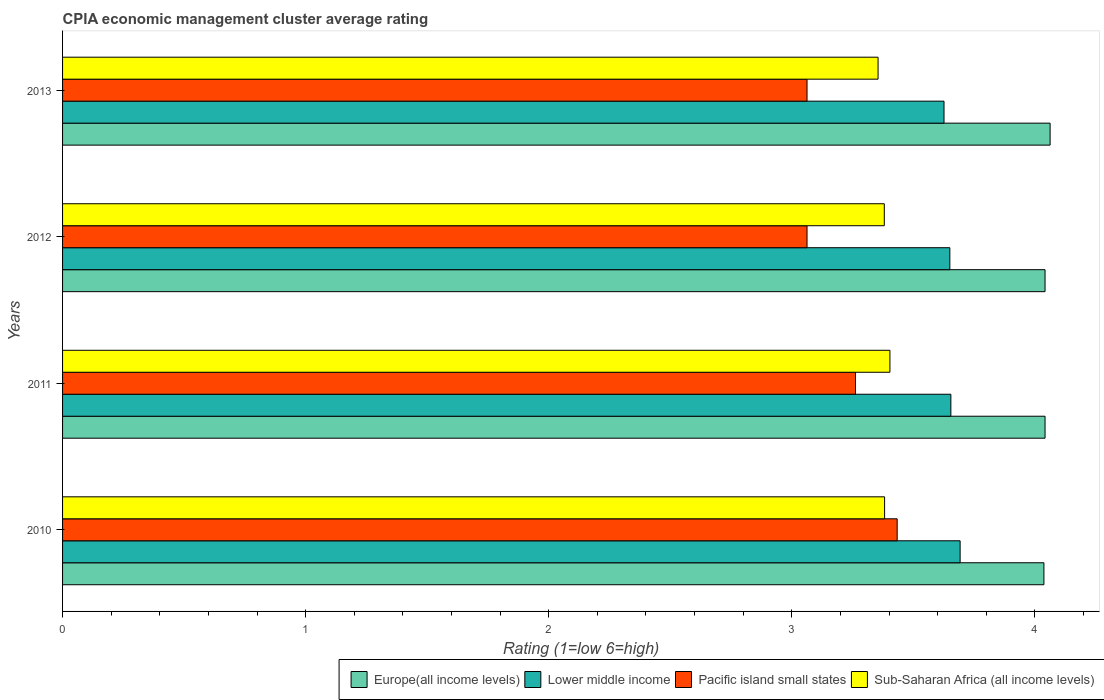How many bars are there on the 3rd tick from the bottom?
Make the answer very short. 4. What is the label of the 1st group of bars from the top?
Give a very brief answer. 2013. What is the CPIA rating in Pacific island small states in 2013?
Your response must be concise. 3.06. Across all years, what is the maximum CPIA rating in Europe(all income levels)?
Provide a succinct answer. 4.06. Across all years, what is the minimum CPIA rating in Pacific island small states?
Make the answer very short. 3.06. In which year was the CPIA rating in Pacific island small states maximum?
Offer a very short reply. 2010. What is the total CPIA rating in Lower middle income in the graph?
Offer a terse response. 14.62. What is the difference between the CPIA rating in Europe(all income levels) in 2010 and that in 2012?
Ensure brevity in your answer.  -0. What is the difference between the CPIA rating in Lower middle income in 2010 and the CPIA rating in Pacific island small states in 2012?
Your answer should be compact. 0.63. What is the average CPIA rating in Lower middle income per year?
Make the answer very short. 3.66. In the year 2011, what is the difference between the CPIA rating in Sub-Saharan Africa (all income levels) and CPIA rating in Europe(all income levels)?
Give a very brief answer. -0.64. In how many years, is the CPIA rating in Sub-Saharan Africa (all income levels) greater than 2.6 ?
Offer a terse response. 4. What is the ratio of the CPIA rating in Lower middle income in 2010 to that in 2013?
Make the answer very short. 1.02. What is the difference between the highest and the second highest CPIA rating in Pacific island small states?
Your answer should be very brief. 0.17. What is the difference between the highest and the lowest CPIA rating in Europe(all income levels)?
Give a very brief answer. 0.03. What does the 1st bar from the top in 2010 represents?
Make the answer very short. Sub-Saharan Africa (all income levels). What does the 1st bar from the bottom in 2012 represents?
Keep it short and to the point. Europe(all income levels). Is it the case that in every year, the sum of the CPIA rating in Pacific island small states and CPIA rating in Sub-Saharan Africa (all income levels) is greater than the CPIA rating in Europe(all income levels)?
Provide a succinct answer. Yes. How many bars are there?
Offer a very short reply. 16. How many years are there in the graph?
Your answer should be very brief. 4. What is the difference between two consecutive major ticks on the X-axis?
Give a very brief answer. 1. Does the graph contain any zero values?
Keep it short and to the point. No. Does the graph contain grids?
Provide a short and direct response. No. How are the legend labels stacked?
Provide a succinct answer. Horizontal. What is the title of the graph?
Keep it short and to the point. CPIA economic management cluster average rating. Does "High income" appear as one of the legend labels in the graph?
Provide a short and direct response. No. What is the label or title of the X-axis?
Offer a very short reply. Rating (1=low 6=high). What is the label or title of the Y-axis?
Provide a short and direct response. Years. What is the Rating (1=low 6=high) of Europe(all income levels) in 2010?
Ensure brevity in your answer.  4.04. What is the Rating (1=low 6=high) in Lower middle income in 2010?
Your answer should be very brief. 3.69. What is the Rating (1=low 6=high) in Pacific island small states in 2010?
Your response must be concise. 3.43. What is the Rating (1=low 6=high) in Sub-Saharan Africa (all income levels) in 2010?
Give a very brief answer. 3.38. What is the Rating (1=low 6=high) in Europe(all income levels) in 2011?
Provide a succinct answer. 4.04. What is the Rating (1=low 6=high) of Lower middle income in 2011?
Provide a succinct answer. 3.65. What is the Rating (1=low 6=high) of Pacific island small states in 2011?
Offer a very short reply. 3.26. What is the Rating (1=low 6=high) of Sub-Saharan Africa (all income levels) in 2011?
Keep it short and to the point. 3.4. What is the Rating (1=low 6=high) of Europe(all income levels) in 2012?
Offer a terse response. 4.04. What is the Rating (1=low 6=high) of Lower middle income in 2012?
Ensure brevity in your answer.  3.65. What is the Rating (1=low 6=high) of Pacific island small states in 2012?
Ensure brevity in your answer.  3.06. What is the Rating (1=low 6=high) of Sub-Saharan Africa (all income levels) in 2012?
Ensure brevity in your answer.  3.38. What is the Rating (1=low 6=high) of Europe(all income levels) in 2013?
Keep it short and to the point. 4.06. What is the Rating (1=low 6=high) of Lower middle income in 2013?
Your answer should be compact. 3.63. What is the Rating (1=low 6=high) in Pacific island small states in 2013?
Offer a very short reply. 3.06. What is the Rating (1=low 6=high) of Sub-Saharan Africa (all income levels) in 2013?
Your response must be concise. 3.35. Across all years, what is the maximum Rating (1=low 6=high) in Europe(all income levels)?
Your response must be concise. 4.06. Across all years, what is the maximum Rating (1=low 6=high) of Lower middle income?
Ensure brevity in your answer.  3.69. Across all years, what is the maximum Rating (1=low 6=high) in Pacific island small states?
Keep it short and to the point. 3.43. Across all years, what is the maximum Rating (1=low 6=high) of Sub-Saharan Africa (all income levels)?
Provide a short and direct response. 3.4. Across all years, what is the minimum Rating (1=low 6=high) in Europe(all income levels)?
Ensure brevity in your answer.  4.04. Across all years, what is the minimum Rating (1=low 6=high) of Lower middle income?
Keep it short and to the point. 3.63. Across all years, what is the minimum Rating (1=low 6=high) in Pacific island small states?
Keep it short and to the point. 3.06. Across all years, what is the minimum Rating (1=low 6=high) in Sub-Saharan Africa (all income levels)?
Keep it short and to the point. 3.35. What is the total Rating (1=low 6=high) in Europe(all income levels) in the graph?
Give a very brief answer. 16.18. What is the total Rating (1=low 6=high) in Lower middle income in the graph?
Keep it short and to the point. 14.62. What is the total Rating (1=low 6=high) in Pacific island small states in the graph?
Ensure brevity in your answer.  12.82. What is the total Rating (1=low 6=high) in Sub-Saharan Africa (all income levels) in the graph?
Your answer should be very brief. 13.52. What is the difference between the Rating (1=low 6=high) in Europe(all income levels) in 2010 and that in 2011?
Offer a very short reply. -0. What is the difference between the Rating (1=low 6=high) of Lower middle income in 2010 and that in 2011?
Your answer should be compact. 0.04. What is the difference between the Rating (1=low 6=high) of Pacific island small states in 2010 and that in 2011?
Make the answer very short. 0.17. What is the difference between the Rating (1=low 6=high) of Sub-Saharan Africa (all income levels) in 2010 and that in 2011?
Give a very brief answer. -0.02. What is the difference between the Rating (1=low 6=high) in Europe(all income levels) in 2010 and that in 2012?
Your answer should be very brief. -0. What is the difference between the Rating (1=low 6=high) of Lower middle income in 2010 and that in 2012?
Give a very brief answer. 0.04. What is the difference between the Rating (1=low 6=high) in Pacific island small states in 2010 and that in 2012?
Your response must be concise. 0.37. What is the difference between the Rating (1=low 6=high) in Sub-Saharan Africa (all income levels) in 2010 and that in 2012?
Offer a very short reply. 0. What is the difference between the Rating (1=low 6=high) in Europe(all income levels) in 2010 and that in 2013?
Ensure brevity in your answer.  -0.03. What is the difference between the Rating (1=low 6=high) in Lower middle income in 2010 and that in 2013?
Your answer should be very brief. 0.07. What is the difference between the Rating (1=low 6=high) of Pacific island small states in 2010 and that in 2013?
Your answer should be very brief. 0.37. What is the difference between the Rating (1=low 6=high) of Sub-Saharan Africa (all income levels) in 2010 and that in 2013?
Provide a succinct answer. 0.03. What is the difference between the Rating (1=low 6=high) in Europe(all income levels) in 2011 and that in 2012?
Give a very brief answer. 0. What is the difference between the Rating (1=low 6=high) of Lower middle income in 2011 and that in 2012?
Provide a short and direct response. 0. What is the difference between the Rating (1=low 6=high) in Pacific island small states in 2011 and that in 2012?
Provide a succinct answer. 0.2. What is the difference between the Rating (1=low 6=high) of Sub-Saharan Africa (all income levels) in 2011 and that in 2012?
Offer a very short reply. 0.02. What is the difference between the Rating (1=low 6=high) of Europe(all income levels) in 2011 and that in 2013?
Provide a succinct answer. -0.02. What is the difference between the Rating (1=low 6=high) in Lower middle income in 2011 and that in 2013?
Make the answer very short. 0.03. What is the difference between the Rating (1=low 6=high) of Pacific island small states in 2011 and that in 2013?
Give a very brief answer. 0.2. What is the difference between the Rating (1=low 6=high) of Sub-Saharan Africa (all income levels) in 2011 and that in 2013?
Ensure brevity in your answer.  0.05. What is the difference between the Rating (1=low 6=high) in Europe(all income levels) in 2012 and that in 2013?
Offer a very short reply. -0.02. What is the difference between the Rating (1=low 6=high) of Lower middle income in 2012 and that in 2013?
Your response must be concise. 0.02. What is the difference between the Rating (1=low 6=high) in Pacific island small states in 2012 and that in 2013?
Your response must be concise. 0. What is the difference between the Rating (1=low 6=high) in Sub-Saharan Africa (all income levels) in 2012 and that in 2013?
Give a very brief answer. 0.03. What is the difference between the Rating (1=low 6=high) in Europe(all income levels) in 2010 and the Rating (1=low 6=high) in Lower middle income in 2011?
Provide a short and direct response. 0.38. What is the difference between the Rating (1=low 6=high) of Europe(all income levels) in 2010 and the Rating (1=low 6=high) of Pacific island small states in 2011?
Provide a short and direct response. 0.78. What is the difference between the Rating (1=low 6=high) in Europe(all income levels) in 2010 and the Rating (1=low 6=high) in Sub-Saharan Africa (all income levels) in 2011?
Offer a very short reply. 0.63. What is the difference between the Rating (1=low 6=high) in Lower middle income in 2010 and the Rating (1=low 6=high) in Pacific island small states in 2011?
Offer a terse response. 0.43. What is the difference between the Rating (1=low 6=high) in Lower middle income in 2010 and the Rating (1=low 6=high) in Sub-Saharan Africa (all income levels) in 2011?
Ensure brevity in your answer.  0.29. What is the difference between the Rating (1=low 6=high) in Pacific island small states in 2010 and the Rating (1=low 6=high) in Sub-Saharan Africa (all income levels) in 2011?
Your answer should be very brief. 0.03. What is the difference between the Rating (1=low 6=high) in Europe(all income levels) in 2010 and the Rating (1=low 6=high) in Lower middle income in 2012?
Provide a short and direct response. 0.39. What is the difference between the Rating (1=low 6=high) of Europe(all income levels) in 2010 and the Rating (1=low 6=high) of Pacific island small states in 2012?
Make the answer very short. 0.97. What is the difference between the Rating (1=low 6=high) in Europe(all income levels) in 2010 and the Rating (1=low 6=high) in Sub-Saharan Africa (all income levels) in 2012?
Make the answer very short. 0.66. What is the difference between the Rating (1=low 6=high) of Lower middle income in 2010 and the Rating (1=low 6=high) of Pacific island small states in 2012?
Offer a terse response. 0.63. What is the difference between the Rating (1=low 6=high) of Lower middle income in 2010 and the Rating (1=low 6=high) of Sub-Saharan Africa (all income levels) in 2012?
Offer a terse response. 0.31. What is the difference between the Rating (1=low 6=high) of Pacific island small states in 2010 and the Rating (1=low 6=high) of Sub-Saharan Africa (all income levels) in 2012?
Provide a short and direct response. 0.05. What is the difference between the Rating (1=low 6=high) in Europe(all income levels) in 2010 and the Rating (1=low 6=high) in Lower middle income in 2013?
Provide a short and direct response. 0.41. What is the difference between the Rating (1=low 6=high) in Europe(all income levels) in 2010 and the Rating (1=low 6=high) in Pacific island small states in 2013?
Your answer should be compact. 0.97. What is the difference between the Rating (1=low 6=high) in Europe(all income levels) in 2010 and the Rating (1=low 6=high) in Sub-Saharan Africa (all income levels) in 2013?
Your answer should be very brief. 0.68. What is the difference between the Rating (1=low 6=high) in Lower middle income in 2010 and the Rating (1=low 6=high) in Pacific island small states in 2013?
Your answer should be compact. 0.63. What is the difference between the Rating (1=low 6=high) of Lower middle income in 2010 and the Rating (1=low 6=high) of Sub-Saharan Africa (all income levels) in 2013?
Your answer should be very brief. 0.34. What is the difference between the Rating (1=low 6=high) of Pacific island small states in 2010 and the Rating (1=low 6=high) of Sub-Saharan Africa (all income levels) in 2013?
Your answer should be compact. 0.08. What is the difference between the Rating (1=low 6=high) of Europe(all income levels) in 2011 and the Rating (1=low 6=high) of Lower middle income in 2012?
Provide a short and direct response. 0.39. What is the difference between the Rating (1=low 6=high) in Europe(all income levels) in 2011 and the Rating (1=low 6=high) in Pacific island small states in 2012?
Your response must be concise. 0.98. What is the difference between the Rating (1=low 6=high) of Europe(all income levels) in 2011 and the Rating (1=low 6=high) of Sub-Saharan Africa (all income levels) in 2012?
Your answer should be very brief. 0.66. What is the difference between the Rating (1=low 6=high) in Lower middle income in 2011 and the Rating (1=low 6=high) in Pacific island small states in 2012?
Ensure brevity in your answer.  0.59. What is the difference between the Rating (1=low 6=high) in Lower middle income in 2011 and the Rating (1=low 6=high) in Sub-Saharan Africa (all income levels) in 2012?
Offer a very short reply. 0.27. What is the difference between the Rating (1=low 6=high) in Pacific island small states in 2011 and the Rating (1=low 6=high) in Sub-Saharan Africa (all income levels) in 2012?
Give a very brief answer. -0.12. What is the difference between the Rating (1=low 6=high) of Europe(all income levels) in 2011 and the Rating (1=low 6=high) of Lower middle income in 2013?
Keep it short and to the point. 0.42. What is the difference between the Rating (1=low 6=high) of Europe(all income levels) in 2011 and the Rating (1=low 6=high) of Pacific island small states in 2013?
Ensure brevity in your answer.  0.98. What is the difference between the Rating (1=low 6=high) of Europe(all income levels) in 2011 and the Rating (1=low 6=high) of Sub-Saharan Africa (all income levels) in 2013?
Make the answer very short. 0.69. What is the difference between the Rating (1=low 6=high) of Lower middle income in 2011 and the Rating (1=low 6=high) of Pacific island small states in 2013?
Offer a very short reply. 0.59. What is the difference between the Rating (1=low 6=high) of Lower middle income in 2011 and the Rating (1=low 6=high) of Sub-Saharan Africa (all income levels) in 2013?
Offer a terse response. 0.3. What is the difference between the Rating (1=low 6=high) in Pacific island small states in 2011 and the Rating (1=low 6=high) in Sub-Saharan Africa (all income levels) in 2013?
Your response must be concise. -0.09. What is the difference between the Rating (1=low 6=high) of Europe(all income levels) in 2012 and the Rating (1=low 6=high) of Lower middle income in 2013?
Provide a succinct answer. 0.42. What is the difference between the Rating (1=low 6=high) of Europe(all income levels) in 2012 and the Rating (1=low 6=high) of Pacific island small states in 2013?
Your answer should be compact. 0.98. What is the difference between the Rating (1=low 6=high) of Europe(all income levels) in 2012 and the Rating (1=low 6=high) of Sub-Saharan Africa (all income levels) in 2013?
Keep it short and to the point. 0.69. What is the difference between the Rating (1=low 6=high) of Lower middle income in 2012 and the Rating (1=low 6=high) of Pacific island small states in 2013?
Make the answer very short. 0.59. What is the difference between the Rating (1=low 6=high) in Lower middle income in 2012 and the Rating (1=low 6=high) in Sub-Saharan Africa (all income levels) in 2013?
Ensure brevity in your answer.  0.3. What is the difference between the Rating (1=low 6=high) of Pacific island small states in 2012 and the Rating (1=low 6=high) of Sub-Saharan Africa (all income levels) in 2013?
Keep it short and to the point. -0.29. What is the average Rating (1=low 6=high) of Europe(all income levels) per year?
Make the answer very short. 4.05. What is the average Rating (1=low 6=high) in Lower middle income per year?
Ensure brevity in your answer.  3.66. What is the average Rating (1=low 6=high) of Pacific island small states per year?
Offer a terse response. 3.21. What is the average Rating (1=low 6=high) of Sub-Saharan Africa (all income levels) per year?
Provide a short and direct response. 3.38. In the year 2010, what is the difference between the Rating (1=low 6=high) in Europe(all income levels) and Rating (1=low 6=high) in Lower middle income?
Ensure brevity in your answer.  0.34. In the year 2010, what is the difference between the Rating (1=low 6=high) of Europe(all income levels) and Rating (1=low 6=high) of Pacific island small states?
Your response must be concise. 0.6. In the year 2010, what is the difference between the Rating (1=low 6=high) of Europe(all income levels) and Rating (1=low 6=high) of Sub-Saharan Africa (all income levels)?
Offer a very short reply. 0.66. In the year 2010, what is the difference between the Rating (1=low 6=high) in Lower middle income and Rating (1=low 6=high) in Pacific island small states?
Offer a very short reply. 0.26. In the year 2010, what is the difference between the Rating (1=low 6=high) of Lower middle income and Rating (1=low 6=high) of Sub-Saharan Africa (all income levels)?
Your answer should be compact. 0.31. In the year 2010, what is the difference between the Rating (1=low 6=high) in Pacific island small states and Rating (1=low 6=high) in Sub-Saharan Africa (all income levels)?
Provide a short and direct response. 0.05. In the year 2011, what is the difference between the Rating (1=low 6=high) of Europe(all income levels) and Rating (1=low 6=high) of Lower middle income?
Make the answer very short. 0.39. In the year 2011, what is the difference between the Rating (1=low 6=high) in Europe(all income levels) and Rating (1=low 6=high) in Pacific island small states?
Offer a very short reply. 0.78. In the year 2011, what is the difference between the Rating (1=low 6=high) in Europe(all income levels) and Rating (1=low 6=high) in Sub-Saharan Africa (all income levels)?
Provide a succinct answer. 0.64. In the year 2011, what is the difference between the Rating (1=low 6=high) of Lower middle income and Rating (1=low 6=high) of Pacific island small states?
Make the answer very short. 0.39. In the year 2011, what is the difference between the Rating (1=low 6=high) of Lower middle income and Rating (1=low 6=high) of Sub-Saharan Africa (all income levels)?
Ensure brevity in your answer.  0.25. In the year 2011, what is the difference between the Rating (1=low 6=high) in Pacific island small states and Rating (1=low 6=high) in Sub-Saharan Africa (all income levels)?
Provide a succinct answer. -0.14. In the year 2012, what is the difference between the Rating (1=low 6=high) in Europe(all income levels) and Rating (1=low 6=high) in Lower middle income?
Give a very brief answer. 0.39. In the year 2012, what is the difference between the Rating (1=low 6=high) in Europe(all income levels) and Rating (1=low 6=high) in Pacific island small states?
Ensure brevity in your answer.  0.98. In the year 2012, what is the difference between the Rating (1=low 6=high) of Europe(all income levels) and Rating (1=low 6=high) of Sub-Saharan Africa (all income levels)?
Offer a terse response. 0.66. In the year 2012, what is the difference between the Rating (1=low 6=high) in Lower middle income and Rating (1=low 6=high) in Pacific island small states?
Ensure brevity in your answer.  0.59. In the year 2012, what is the difference between the Rating (1=low 6=high) in Lower middle income and Rating (1=low 6=high) in Sub-Saharan Africa (all income levels)?
Your answer should be compact. 0.27. In the year 2012, what is the difference between the Rating (1=low 6=high) of Pacific island small states and Rating (1=low 6=high) of Sub-Saharan Africa (all income levels)?
Provide a succinct answer. -0.32. In the year 2013, what is the difference between the Rating (1=low 6=high) of Europe(all income levels) and Rating (1=low 6=high) of Lower middle income?
Provide a short and direct response. 0.44. In the year 2013, what is the difference between the Rating (1=low 6=high) of Europe(all income levels) and Rating (1=low 6=high) of Pacific island small states?
Make the answer very short. 1. In the year 2013, what is the difference between the Rating (1=low 6=high) of Europe(all income levels) and Rating (1=low 6=high) of Sub-Saharan Africa (all income levels)?
Make the answer very short. 0.71. In the year 2013, what is the difference between the Rating (1=low 6=high) in Lower middle income and Rating (1=low 6=high) in Pacific island small states?
Provide a short and direct response. 0.56. In the year 2013, what is the difference between the Rating (1=low 6=high) of Lower middle income and Rating (1=low 6=high) of Sub-Saharan Africa (all income levels)?
Your answer should be compact. 0.27. In the year 2013, what is the difference between the Rating (1=low 6=high) in Pacific island small states and Rating (1=low 6=high) in Sub-Saharan Africa (all income levels)?
Your answer should be compact. -0.29. What is the ratio of the Rating (1=low 6=high) of Lower middle income in 2010 to that in 2011?
Offer a terse response. 1.01. What is the ratio of the Rating (1=low 6=high) of Pacific island small states in 2010 to that in 2011?
Make the answer very short. 1.05. What is the ratio of the Rating (1=low 6=high) in Europe(all income levels) in 2010 to that in 2012?
Your answer should be compact. 1. What is the ratio of the Rating (1=low 6=high) of Lower middle income in 2010 to that in 2012?
Your answer should be compact. 1.01. What is the ratio of the Rating (1=low 6=high) of Pacific island small states in 2010 to that in 2012?
Provide a succinct answer. 1.12. What is the ratio of the Rating (1=low 6=high) of Sub-Saharan Africa (all income levels) in 2010 to that in 2012?
Offer a terse response. 1. What is the ratio of the Rating (1=low 6=high) of Lower middle income in 2010 to that in 2013?
Your answer should be compact. 1.02. What is the ratio of the Rating (1=low 6=high) of Pacific island small states in 2010 to that in 2013?
Make the answer very short. 1.12. What is the ratio of the Rating (1=low 6=high) in Pacific island small states in 2011 to that in 2012?
Your answer should be compact. 1.07. What is the ratio of the Rating (1=low 6=high) of Lower middle income in 2011 to that in 2013?
Provide a succinct answer. 1.01. What is the ratio of the Rating (1=low 6=high) of Pacific island small states in 2011 to that in 2013?
Provide a short and direct response. 1.07. What is the ratio of the Rating (1=low 6=high) in Sub-Saharan Africa (all income levels) in 2011 to that in 2013?
Your answer should be very brief. 1.01. What is the ratio of the Rating (1=low 6=high) in Europe(all income levels) in 2012 to that in 2013?
Your answer should be very brief. 0.99. What is the ratio of the Rating (1=low 6=high) in Lower middle income in 2012 to that in 2013?
Offer a very short reply. 1.01. What is the ratio of the Rating (1=low 6=high) of Pacific island small states in 2012 to that in 2013?
Your response must be concise. 1. What is the ratio of the Rating (1=low 6=high) in Sub-Saharan Africa (all income levels) in 2012 to that in 2013?
Offer a very short reply. 1.01. What is the difference between the highest and the second highest Rating (1=low 6=high) of Europe(all income levels)?
Offer a terse response. 0.02. What is the difference between the highest and the second highest Rating (1=low 6=high) in Lower middle income?
Your response must be concise. 0.04. What is the difference between the highest and the second highest Rating (1=low 6=high) of Pacific island small states?
Make the answer very short. 0.17. What is the difference between the highest and the second highest Rating (1=low 6=high) in Sub-Saharan Africa (all income levels)?
Provide a short and direct response. 0.02. What is the difference between the highest and the lowest Rating (1=low 6=high) of Europe(all income levels)?
Your response must be concise. 0.03. What is the difference between the highest and the lowest Rating (1=low 6=high) of Lower middle income?
Your response must be concise. 0.07. What is the difference between the highest and the lowest Rating (1=low 6=high) of Pacific island small states?
Your response must be concise. 0.37. What is the difference between the highest and the lowest Rating (1=low 6=high) of Sub-Saharan Africa (all income levels)?
Make the answer very short. 0.05. 